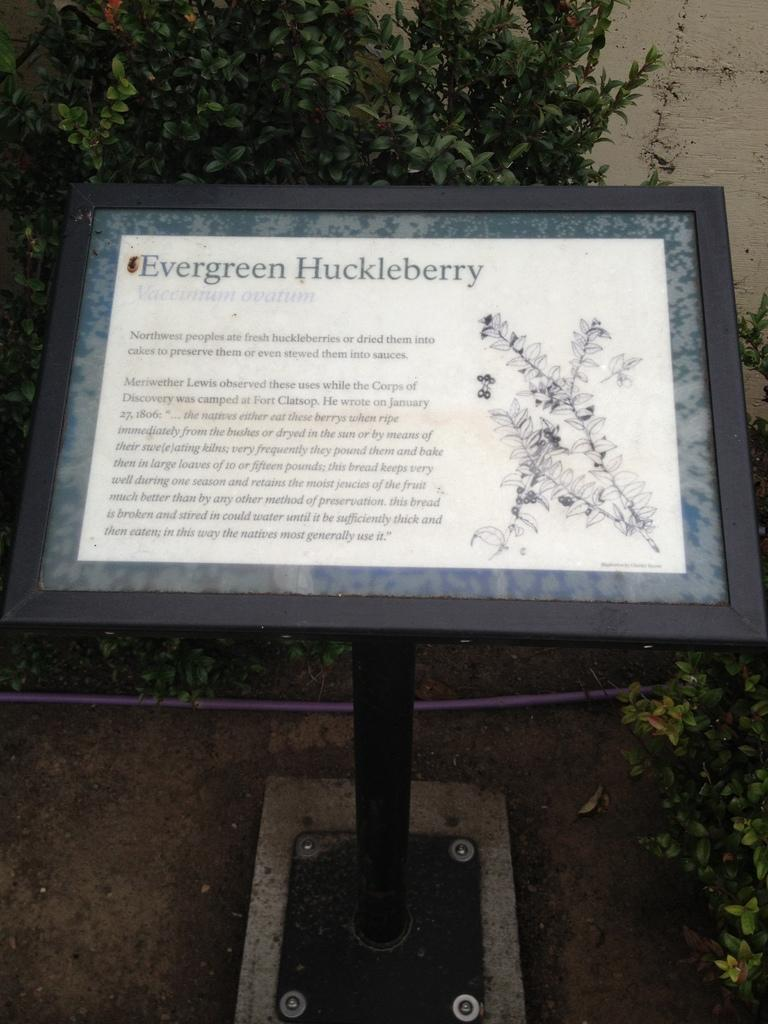What is on the board that is visible in the image? There is a board with text in the image. What can be seen in the background of the image? There are plants and a wall in the background of the image. What type of apparel is the queen wearing in the image? There is no queen or apparel present in the image; it only features a board with text and a background with plants and a wall. 